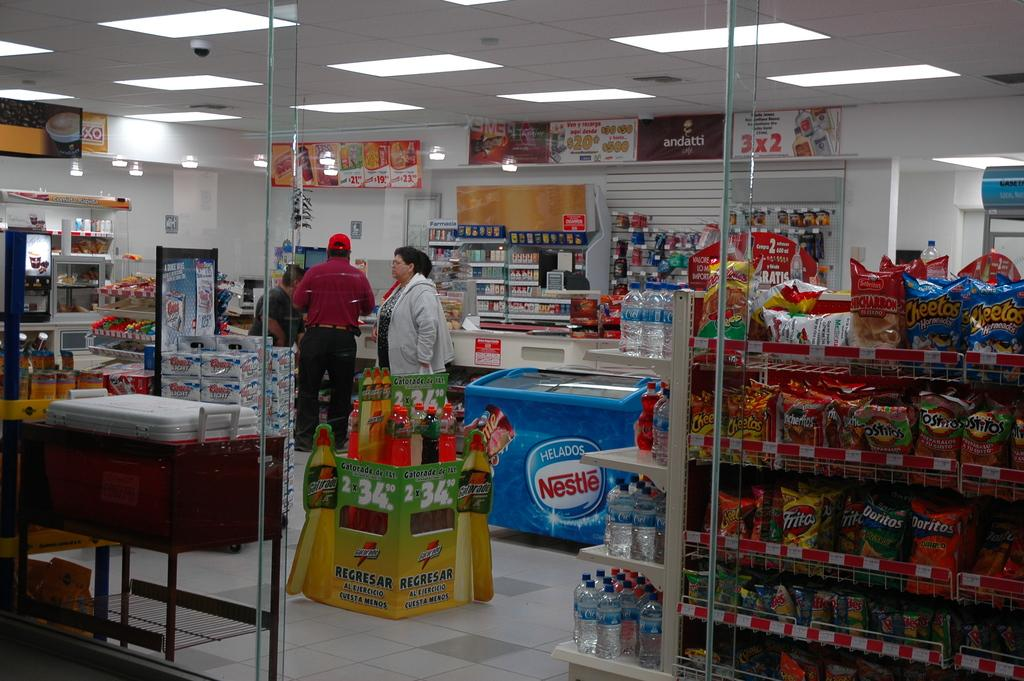<image>
Relay a brief, clear account of the picture shown. An Andatti banner in the background of a convenience store with a nestle cooler in it. 